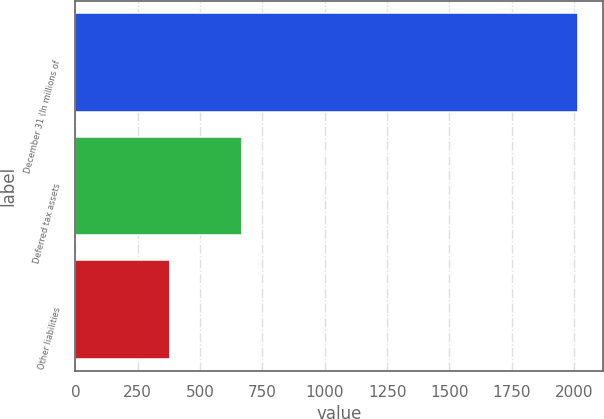Convert chart to OTSL. <chart><loc_0><loc_0><loc_500><loc_500><bar_chart><fcel>December 31 (In millions of<fcel>Deferred tax assets<fcel>Other liabilities<nl><fcel>2017<fcel>669<fcel>381<nl></chart> 